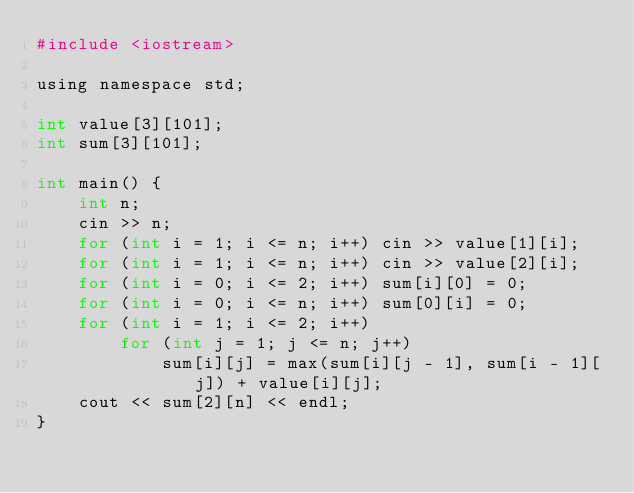Convert code to text. <code><loc_0><loc_0><loc_500><loc_500><_Awk_>#include <iostream>

using namespace std;

int value[3][101];
int sum[3][101];

int main() {
	int n;
	cin >> n;
	for (int i = 1; i <= n; i++) cin >> value[1][i];
	for (int i = 1; i <= n; i++) cin >> value[2][i];
	for (int i = 0; i <= 2; i++) sum[i][0] = 0;
	for (int i = 0; i <= n; i++) sum[0][i] = 0;
	for (int i = 1; i <= 2; i++)
		for (int j = 1; j <= n; j++)
			sum[i][j] = max(sum[i][j - 1], sum[i - 1][j]) + value[i][j];
	cout << sum[2][n] << endl;
}</code> 